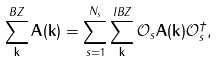<formula> <loc_0><loc_0><loc_500><loc_500>\sum _ { \mathbf k } ^ { B Z } { \mathbf A } ( { \mathbf k } ) = \sum _ { s = 1 } ^ { N _ { s } } \sum _ { \mathbf k } ^ { I B Z } { \mathcal { O } } _ { s } { \mathbf A } ( { \mathbf k } ) { \mathcal { O } } _ { s } ^ { \dagger } ,</formula> 